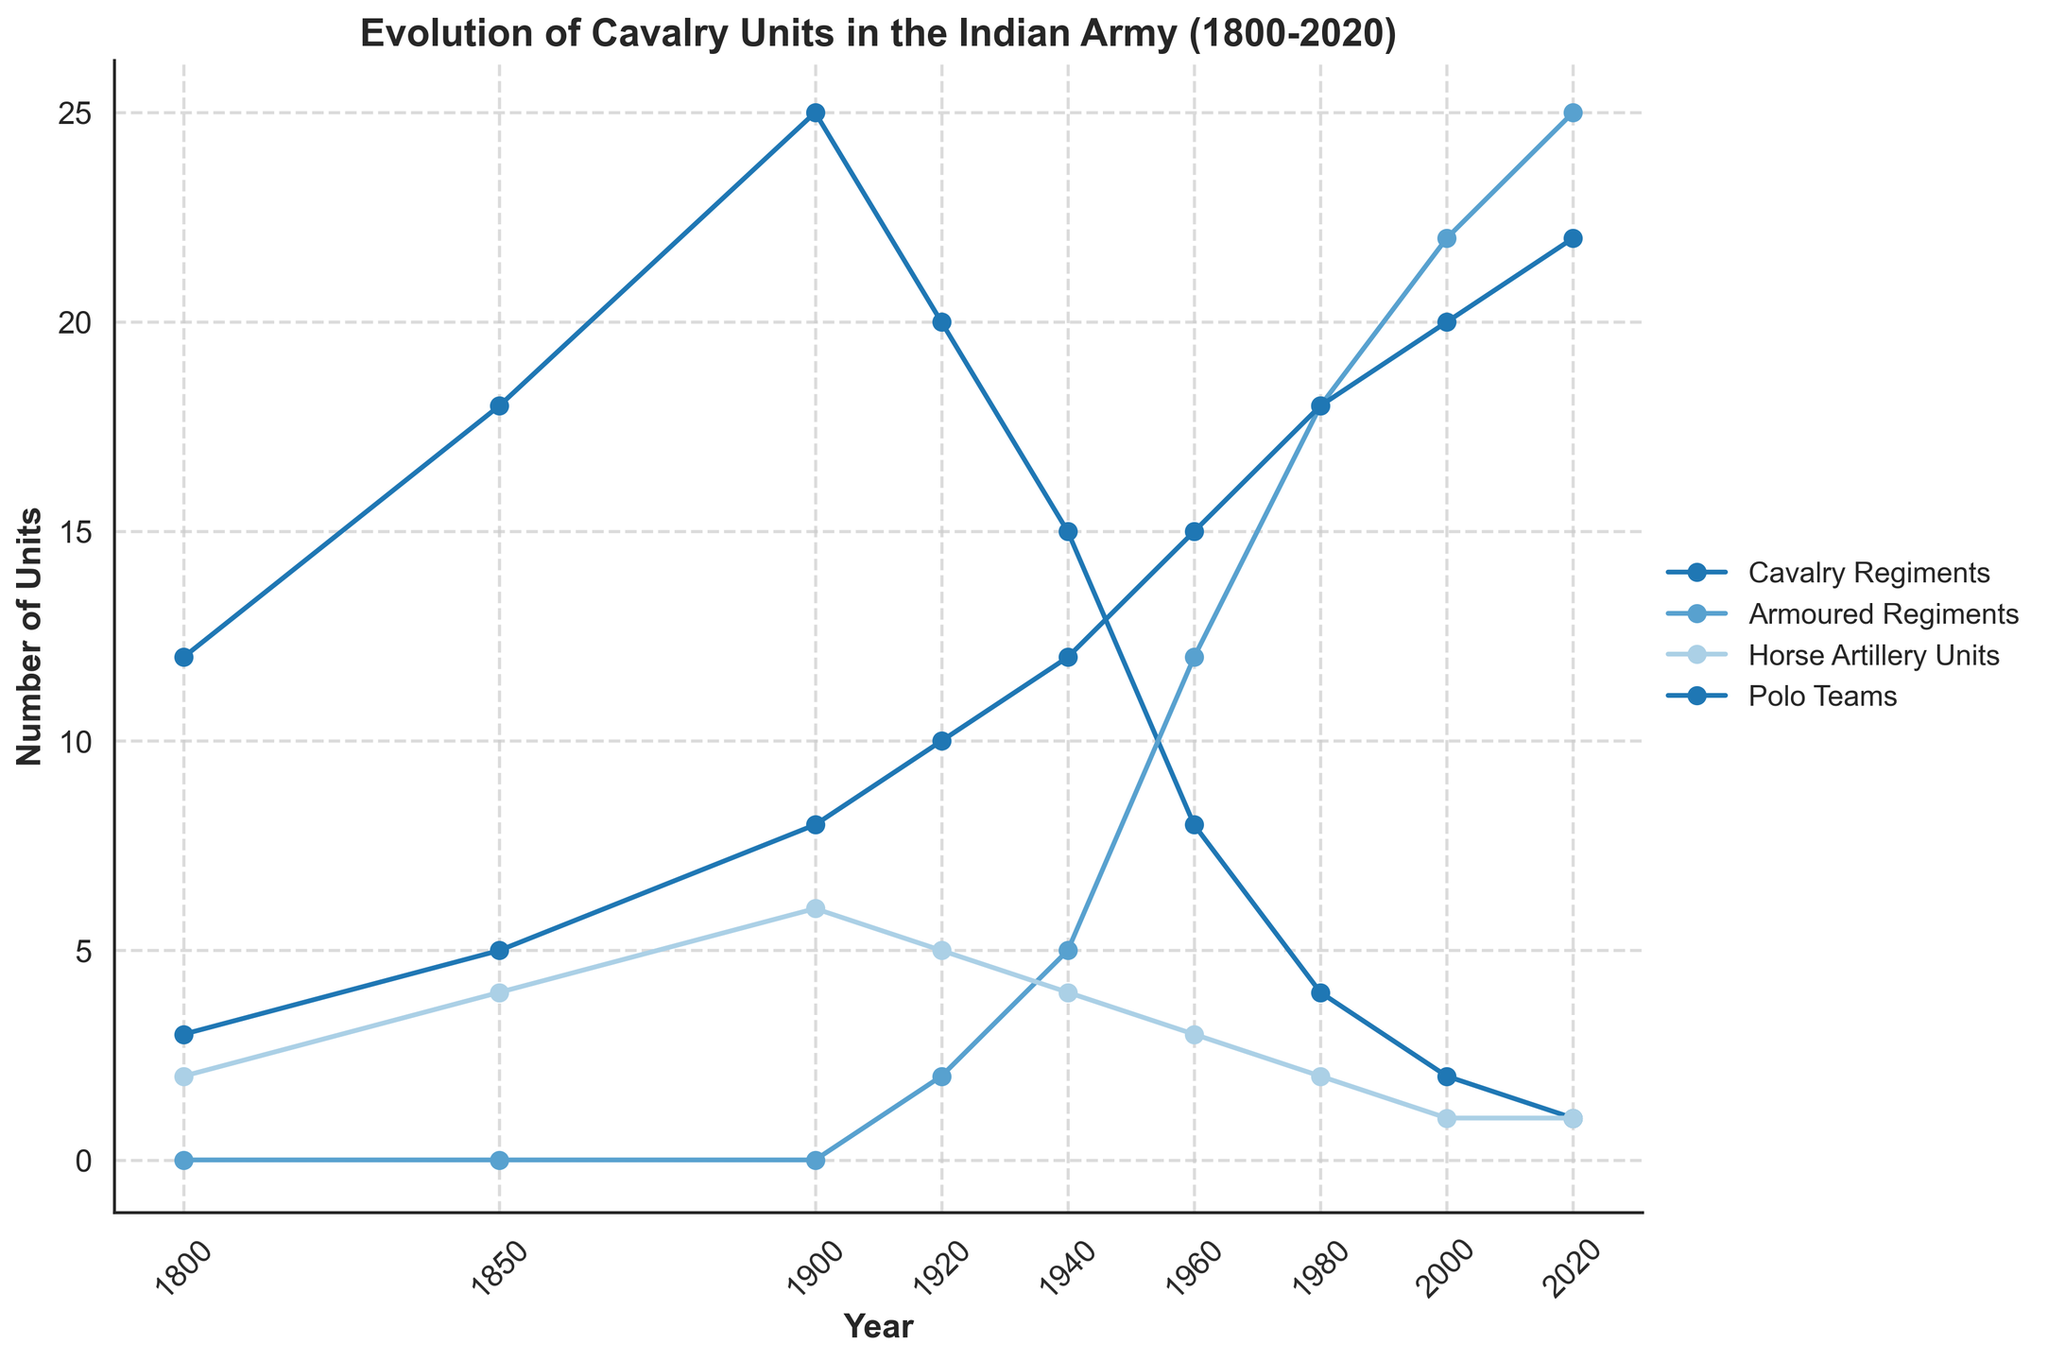How many Cavalry Regiments were there in 1920? To find the number of Cavalry Regiments in 1920, look for the data point on the line representing "Cavalry Regiments" corresponding to the year 1920.
Answer: 20 Which year had the maximum number of Armoured Regiments? Locate the peak point on the line representing "Armoured Regiments" and identify the year associated with this peak.
Answer: 2020 In 1900, how many more Horse Artillery Units were there compared to Cavalry Regiments in 2020? Find the number of Horse Artillery Units in 1900 and the number of Cavalry Regiments in 2020. Then, subtract the Cavalry Regiments in 2020 from the Horse Artillery Units in 1900 (6 - 1).
Answer: 5 What is the general trend of Polo Teams from 1800 to 2020? Track the line representing "Polo Teams" from 1800 to 2020 and observe if it generally increases, decreases, or remains constant.
Answer: Increases How did the number of Cavalry Regiments change between 1850 and 2000? Locate the number of Cavalry Regiments in 1850 and in 2000, then observe the change (18 in 1850 to 2 in 2000).
Answer: Decreased Which unit type consistently increased over the years? Examine each line over the years to find which unit type continuously rises without significant drops.
Answer: Polo Teams What is the difference in the number of Horse Artillery Units between 1920 and 1980? Find the number of Horse Artillery Units in both years (5 in 1920 and 2 in 1980) and calculate the difference (5 - 2).
Answer: 3 How many Polo Teams were there in 1960 compared to 2000? Look at the line for "Polo Teams" and find the data points for the years 1960 and 2000 (15 in 1960 and 20 in 2000).
Answer: 5 more in 2000 Which year first saw the appearance of Armoured Regiments? Identify the first year on the "Armoured Regiments" line where the value is greater than zero.
Answer: 1920 How does the number of Cavalry Regiments in 1800 compare to the total number of all units in 2020? Sum the number of all unit types in 2020 (1 Cavalry Regiment + 25 Armoured Regiments + 1 Horse Artillery Unit + 22 Polo Teams = 49) and compare it to the number of Cavalry Regiments in 1800 (12).
Answer: 37 more in 2020 